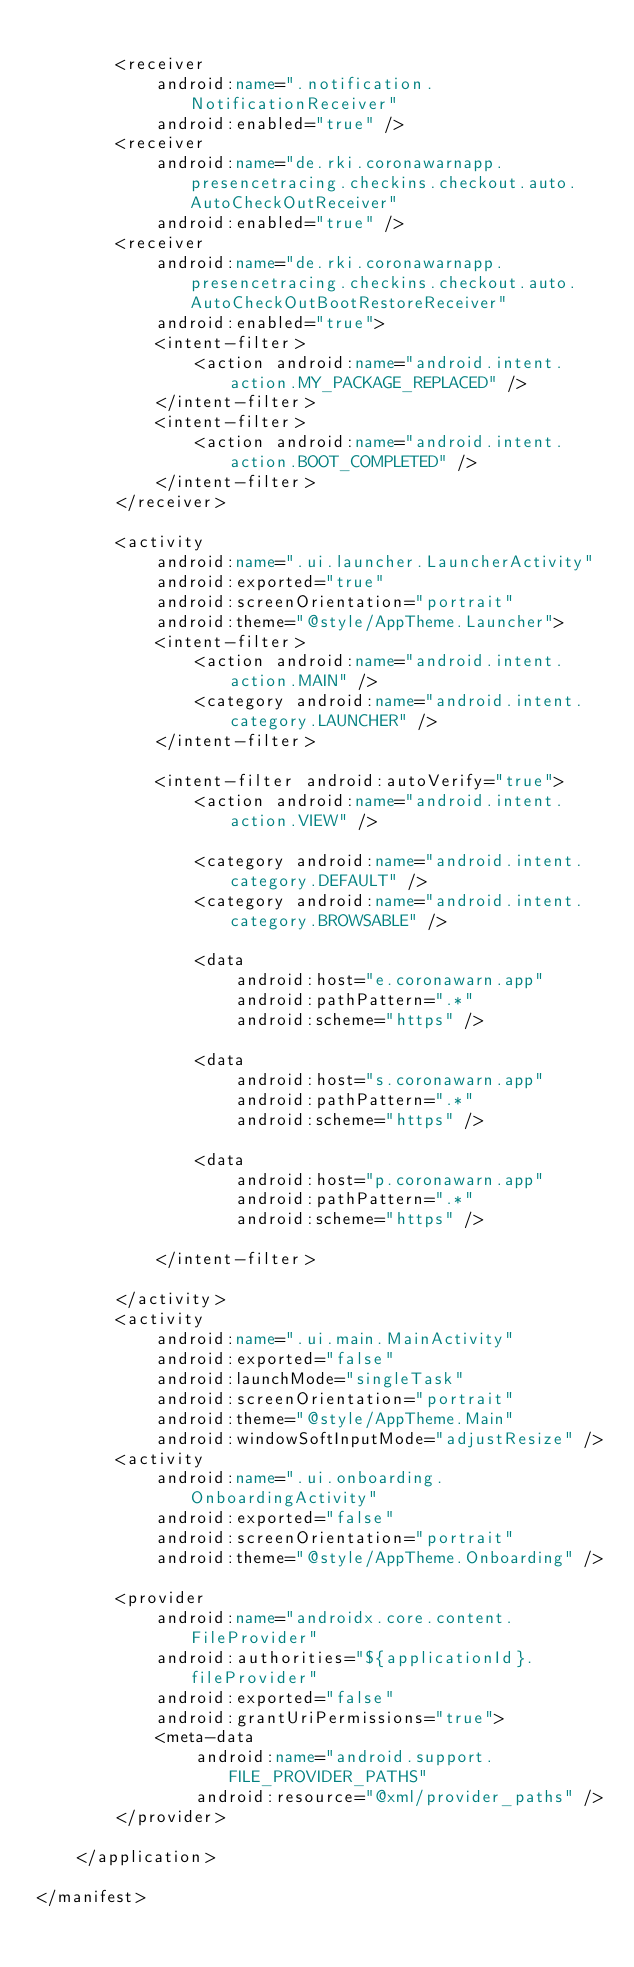Convert code to text. <code><loc_0><loc_0><loc_500><loc_500><_XML_>
        <receiver
            android:name=".notification.NotificationReceiver"
            android:enabled="true" />
        <receiver
            android:name="de.rki.coronawarnapp.presencetracing.checkins.checkout.auto.AutoCheckOutReceiver"
            android:enabled="true" />
        <receiver
            android:name="de.rki.coronawarnapp.presencetracing.checkins.checkout.auto.AutoCheckOutBootRestoreReceiver"
            android:enabled="true">
            <intent-filter>
                <action android:name="android.intent.action.MY_PACKAGE_REPLACED" />
            </intent-filter>
            <intent-filter>
                <action android:name="android.intent.action.BOOT_COMPLETED" />
            </intent-filter>
        </receiver>

        <activity
            android:name=".ui.launcher.LauncherActivity"
            android:exported="true"
            android:screenOrientation="portrait"
            android:theme="@style/AppTheme.Launcher">
            <intent-filter>
                <action android:name="android.intent.action.MAIN" />
                <category android:name="android.intent.category.LAUNCHER" />
            </intent-filter>

            <intent-filter android:autoVerify="true">
                <action android:name="android.intent.action.VIEW" />

                <category android:name="android.intent.category.DEFAULT" />
                <category android:name="android.intent.category.BROWSABLE" />

                <data
                    android:host="e.coronawarn.app"
                    android:pathPattern=".*"
                    android:scheme="https" />

                <data
                    android:host="s.coronawarn.app"
                    android:pathPattern=".*"
                    android:scheme="https" />

                <data
                    android:host="p.coronawarn.app"
                    android:pathPattern=".*"
                    android:scheme="https" />

            </intent-filter>

        </activity>
        <activity
            android:name=".ui.main.MainActivity"
            android:exported="false"
            android:launchMode="singleTask"
            android:screenOrientation="portrait"
            android:theme="@style/AppTheme.Main"
            android:windowSoftInputMode="adjustResize" />
        <activity
            android:name=".ui.onboarding.OnboardingActivity"
            android:exported="false"
            android:screenOrientation="portrait"
            android:theme="@style/AppTheme.Onboarding" />

        <provider
            android:name="androidx.core.content.FileProvider"
            android:authorities="${applicationId}.fileProvider"
            android:exported="false"
            android:grantUriPermissions="true">
            <meta-data
                android:name="android.support.FILE_PROVIDER_PATHS"
                android:resource="@xml/provider_paths" />
        </provider>

    </application>

</manifest>
</code> 